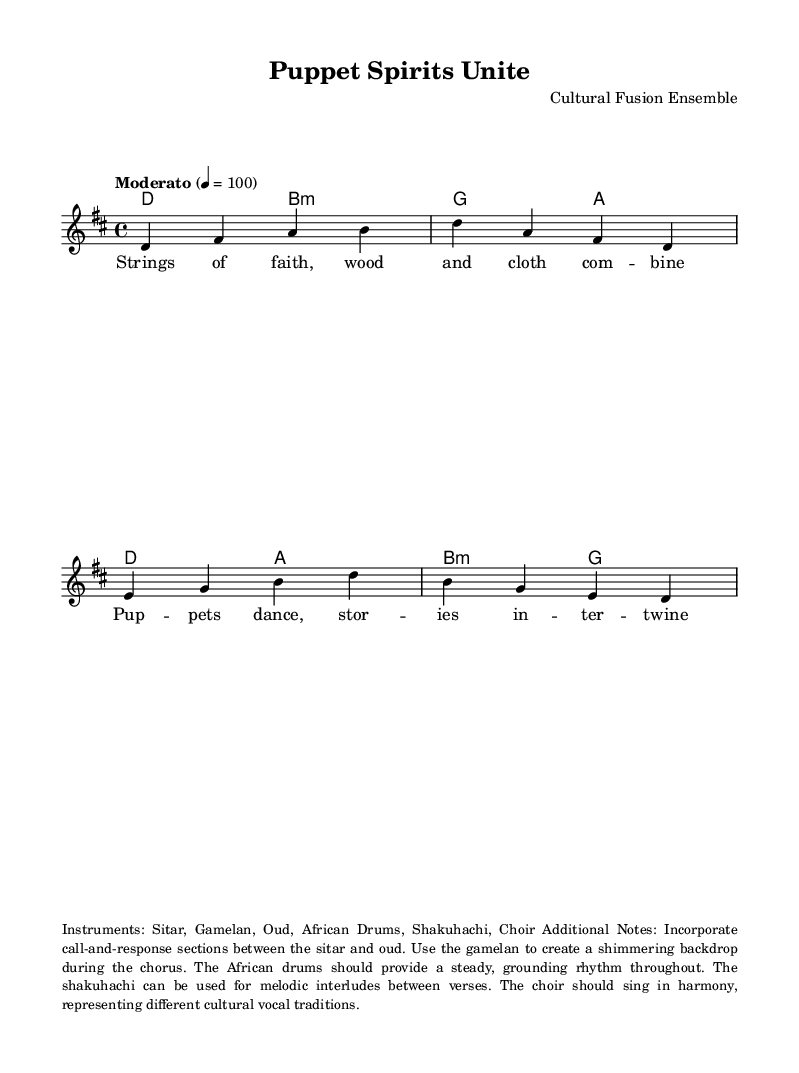What is the key signature of this music? The key signature indicates D major, as it includes two sharps (F# and C#).
Answer: D major What is the time signature of the piece? The time signature is indicated at the beginning of the score as 4/4, which means there are four beats in a measure.
Answer: 4/4 What is the tempo marking for this piece? The tempo marking is specified as "Moderato," which is a moderate speed, and it's quantified as 4 beats per minute at 100.
Answer: Moderato What instruments are indicated for this music? The instruments mentioned include Sitar, Gamelan, Oud, African Drums, Shakuhachi, and Choir, all noted in the additional notes section.
Answer: Sitar, Gamelan, Oud, African Drums, Shakuhachi, Choir What type of singing style is indicated in the lyrics? The lyrics suggest a choir is employed, hinting at a harmonic singing style that represents different vocal traditions.
Answer: Choir What kind of rhythmic pattern is suggested to accompany the music? The African drums are noted to provide a steady, grounding rhythm throughout the piece, indicating a consistent rhythmic backdrop.
Answer: Steady grounding rhythm 